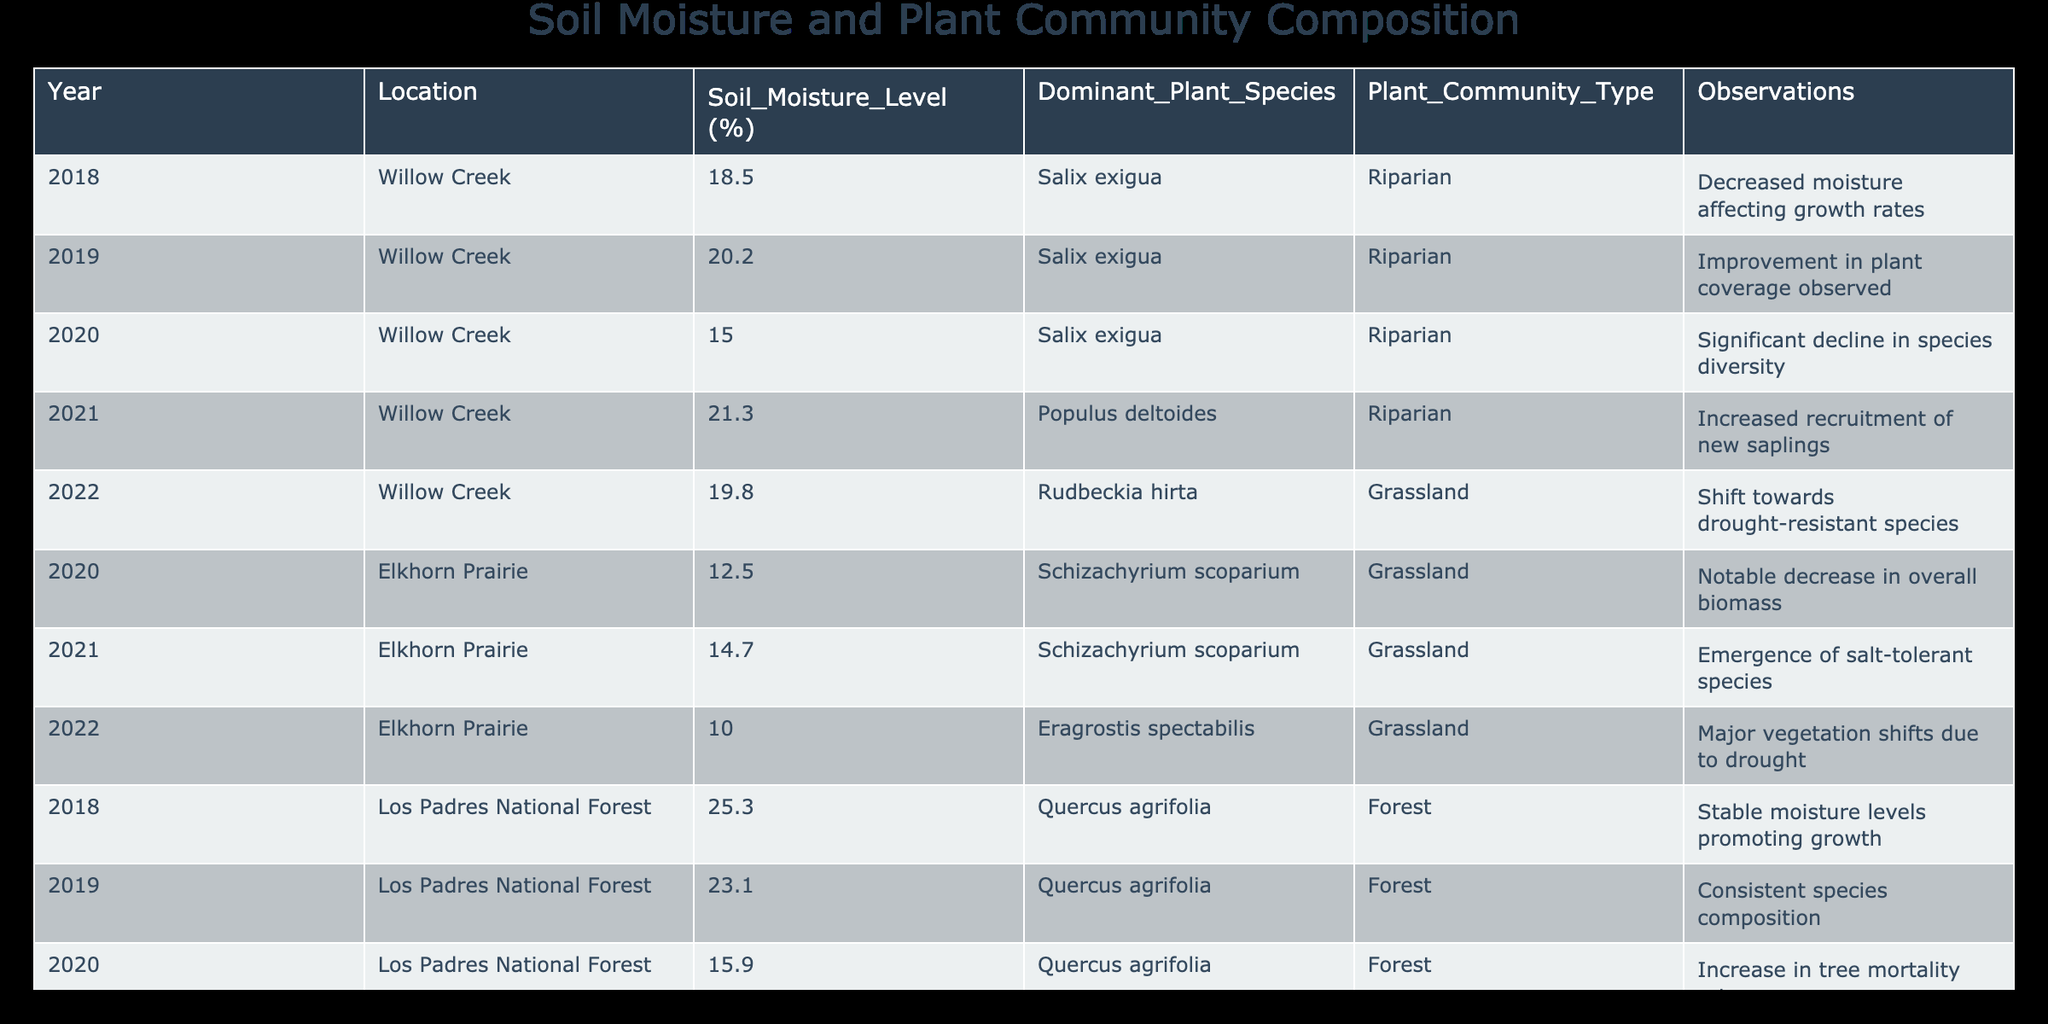What was the dominant plant species in Willow Creek in 2020? From the table, the row for the year 2020 in the location Willow Creek indicates that the dominant plant species was Salix exigua.
Answer: Salix exigua In which year did the soil moisture level in Los Padres National Forest reach its lowest point? By examining the rows for Los Padres National Forest, the lowest soil moisture level is found in the year 2020, which is 15.9%.
Answer: 2020 What is the average soil moisture level for Elkhorn Prairie over the years recorded? The soil moisture levels for Elkhorn Prairie are 12.5% (2020), 14.7% (2021), and 10.0% (2022). To find the average: (12.5 + 14.7 + 10.0) / 3 = 37.2 / 3 = 12.4%.
Answer: 12.4% Did the dominant plant species in Elkhorn Prairie change from 2020 to 2021? In 2020, the dominant plant species was Schizachyrium scoparium, and in 2021, it remained Schizachyrium scoparium. Thus, the dominant species did not change between these years.
Answer: No What change in plant community type is noted at Willow Creek in 2022? The observation for Willow Creek in 2022 indicates a shift towards drought-resistant species, which signifies a change in the plant community type from the previous years focused on Salix exigua.
Answer: Shift towards drought-resistant species How much did the soil moisture level increase from 2018 to 2021 in Willow Creek? The soil moisture level in 2018 was 18.5%, and in 2021 it increased to 21.3%. The difference is calculated: 21.3 - 18.5 = 2.8%.
Answer: 2.8% Is there any observation noted for a major decline in tree species in Los Padres National Forest? Yes, in 2020, there was an observation indicating an increase in tree mortality rates in Los Padres National Forest, suggesting a decline in tree species.
Answer: Yes In which plant community type did Schizachyrium scoparium dominate? From the data, Schizachyrium scoparium dominated the Grassland community type both in 2020 and 2021.
Answer: Grassland What trend is observed regarding soil moisture levels at Elkhorn Prairie from 2020 to 2022? The soil moisture levels at Elkhorn Prairie show a declining trend: it was 12.5% in 2020, decreased to 10.0% in 2022, indicating worsening moisture conditions for vegetation.
Answer: Declining trend 